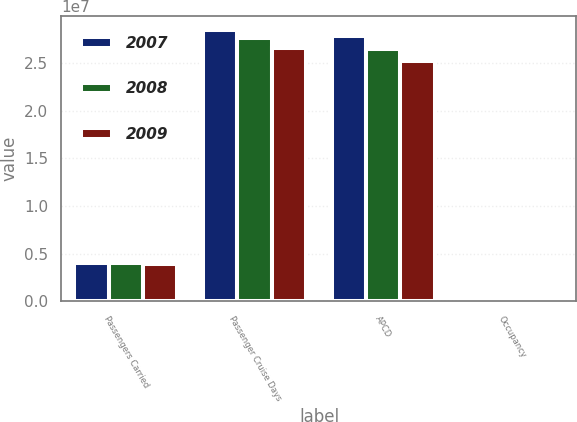Convert chart to OTSL. <chart><loc_0><loc_0><loc_500><loc_500><stacked_bar_chart><ecel><fcel>Passengers Carried<fcel>Passenger Cruise Days<fcel>APCD<fcel>Occupancy<nl><fcel>2007<fcel>3.97028e+06<fcel>2.8503e+07<fcel>2.78212e+07<fcel>102.5<nl><fcel>2008<fcel>4.01755e+06<fcel>2.76576e+07<fcel>2.64636e+07<fcel>104.5<nl><fcel>2009<fcel>3.90538e+06<fcel>2.65945e+07<fcel>2.51558e+07<fcel>105.7<nl></chart> 